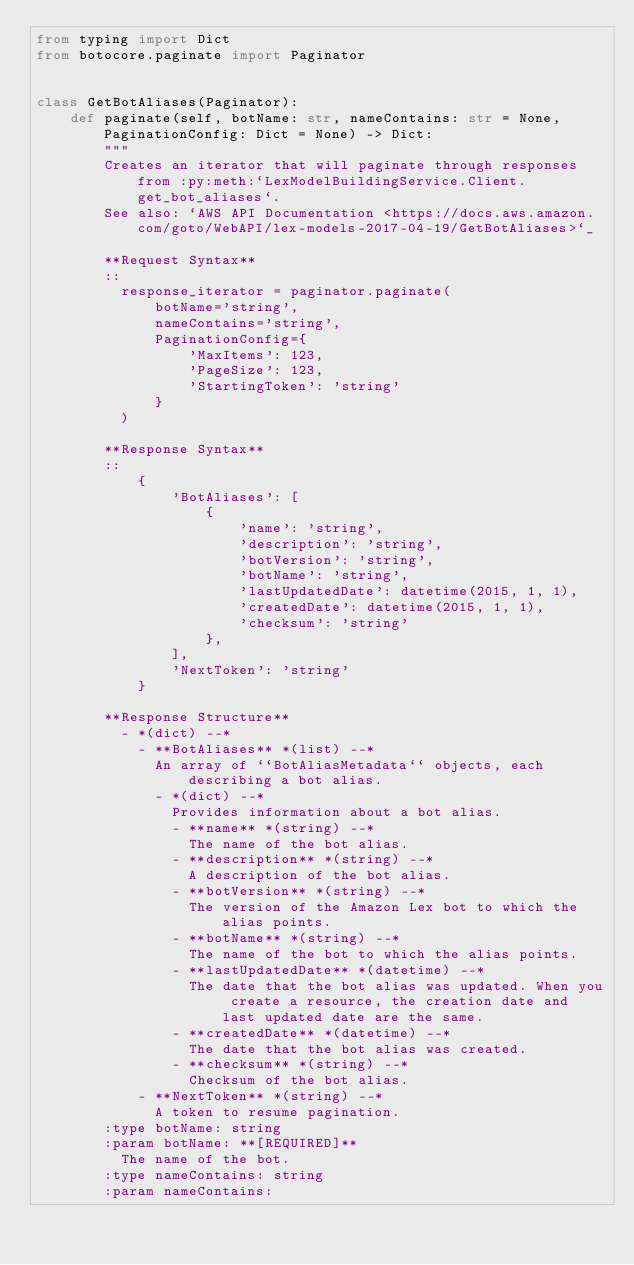Convert code to text. <code><loc_0><loc_0><loc_500><loc_500><_Python_>from typing import Dict
from botocore.paginate import Paginator


class GetBotAliases(Paginator):
    def paginate(self, botName: str, nameContains: str = None, PaginationConfig: Dict = None) -> Dict:
        """
        Creates an iterator that will paginate through responses from :py:meth:`LexModelBuildingService.Client.get_bot_aliases`.
        See also: `AWS API Documentation <https://docs.aws.amazon.com/goto/WebAPI/lex-models-2017-04-19/GetBotAliases>`_
        
        **Request Syntax**
        ::
          response_iterator = paginator.paginate(
              botName='string',
              nameContains='string',
              PaginationConfig={
                  'MaxItems': 123,
                  'PageSize': 123,
                  'StartingToken': 'string'
              }
          )
        
        **Response Syntax**
        ::
            {
                'BotAliases': [
                    {
                        'name': 'string',
                        'description': 'string',
                        'botVersion': 'string',
                        'botName': 'string',
                        'lastUpdatedDate': datetime(2015, 1, 1),
                        'createdDate': datetime(2015, 1, 1),
                        'checksum': 'string'
                    },
                ],
                'NextToken': 'string'
            }
        
        **Response Structure**
          - *(dict) --* 
            - **BotAliases** *(list) --* 
              An array of ``BotAliasMetadata`` objects, each describing a bot alias.
              - *(dict) --* 
                Provides information about a bot alias.
                - **name** *(string) --* 
                  The name of the bot alias.
                - **description** *(string) --* 
                  A description of the bot alias.
                - **botVersion** *(string) --* 
                  The version of the Amazon Lex bot to which the alias points.
                - **botName** *(string) --* 
                  The name of the bot to which the alias points.
                - **lastUpdatedDate** *(datetime) --* 
                  The date that the bot alias was updated. When you create a resource, the creation date and last updated date are the same.
                - **createdDate** *(datetime) --* 
                  The date that the bot alias was created.
                - **checksum** *(string) --* 
                  Checksum of the bot alias.
            - **NextToken** *(string) --* 
              A token to resume pagination.
        :type botName: string
        :param botName: **[REQUIRED]**
          The name of the bot.
        :type nameContains: string
        :param nameContains:</code> 